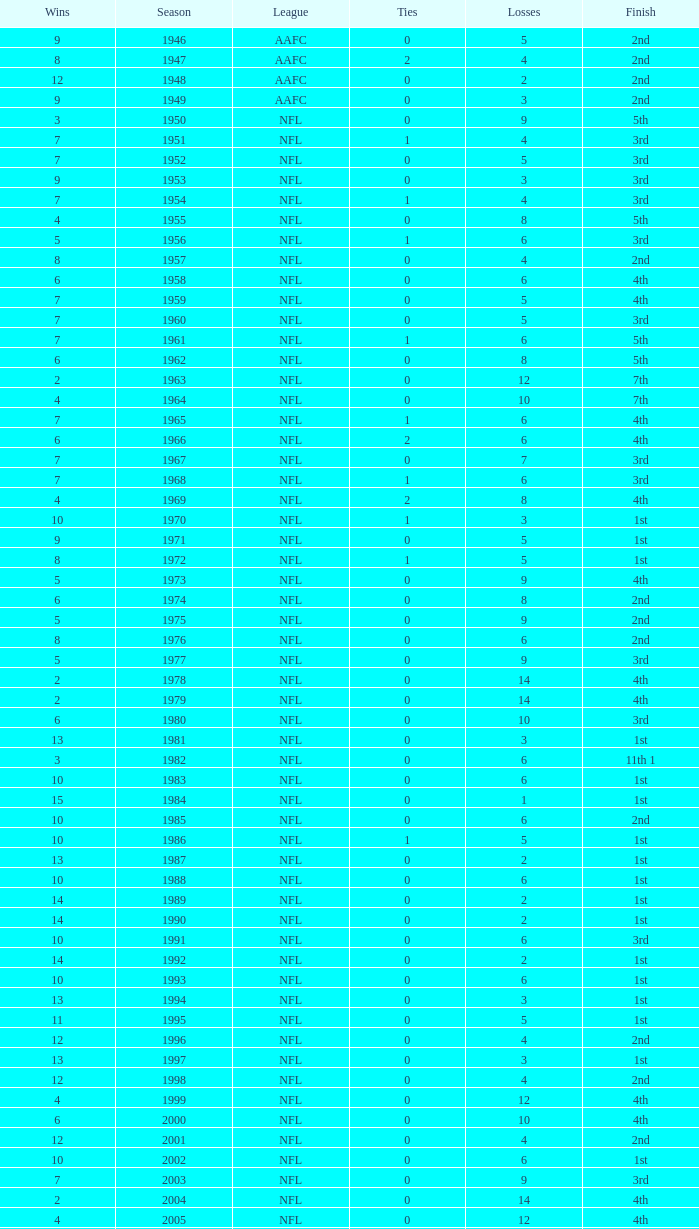What is the highest wins for the NFL with a finish of 1st, and more than 6 losses? None. 